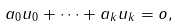<formula> <loc_0><loc_0><loc_500><loc_500>a _ { 0 } u _ { 0 } + \cdots + a _ { k } u _ { k } = o ,</formula> 